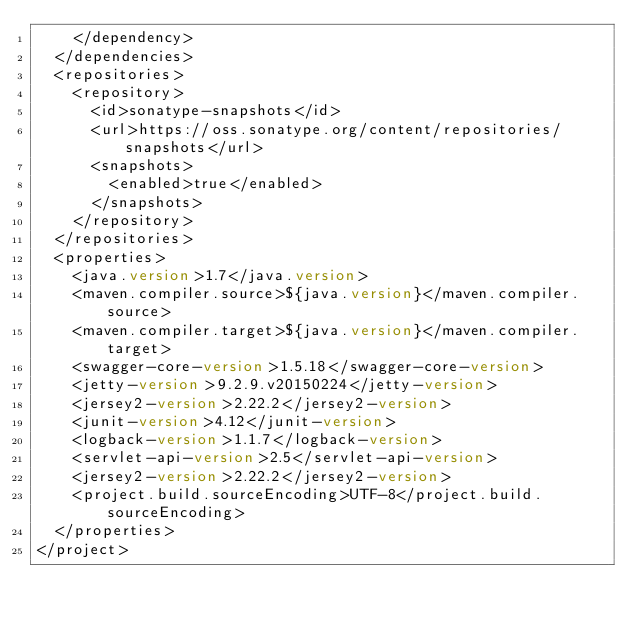Convert code to text. <code><loc_0><loc_0><loc_500><loc_500><_XML_>    </dependency> 
  </dependencies>
  <repositories>
    <repository>
      <id>sonatype-snapshots</id>
      <url>https://oss.sonatype.org/content/repositories/snapshots</url>
      <snapshots>
        <enabled>true</enabled>
      </snapshots>
    </repository>
  </repositories>
  <properties>
    <java.version>1.7</java.version>
    <maven.compiler.source>${java.version}</maven.compiler.source>
    <maven.compiler.target>${java.version}</maven.compiler.target>
    <swagger-core-version>1.5.18</swagger-core-version>
    <jetty-version>9.2.9.v20150224</jetty-version>
    <jersey2-version>2.22.2</jersey2-version>
    <junit-version>4.12</junit-version>
    <logback-version>1.1.7</logback-version>
    <servlet-api-version>2.5</servlet-api-version>
    <jersey2-version>2.22.2</jersey2-version>
    <project.build.sourceEncoding>UTF-8</project.build.sourceEncoding>
  </properties>
</project>
</code> 